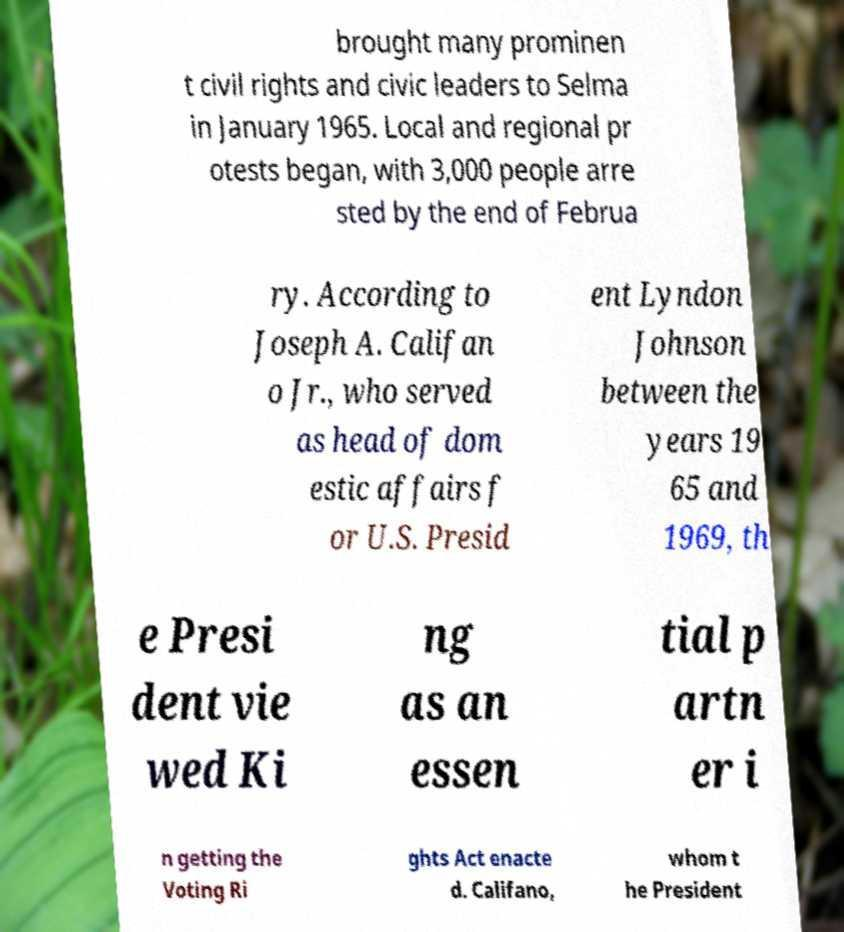Please identify and transcribe the text found in this image. brought many prominen t civil rights and civic leaders to Selma in January 1965. Local and regional pr otests began, with 3,000 people arre sted by the end of Februa ry. According to Joseph A. Califan o Jr., who served as head of dom estic affairs f or U.S. Presid ent Lyndon Johnson between the years 19 65 and 1969, th e Presi dent vie wed Ki ng as an essen tial p artn er i n getting the Voting Ri ghts Act enacte d. Califano, whom t he President 